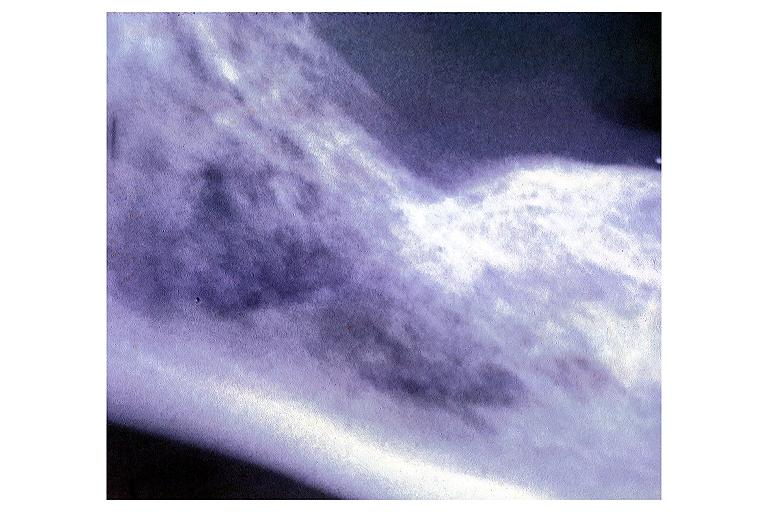does metastatic carcinoma lung show metastatic adenocarcinoma?
Answer the question using a single word or phrase. No 